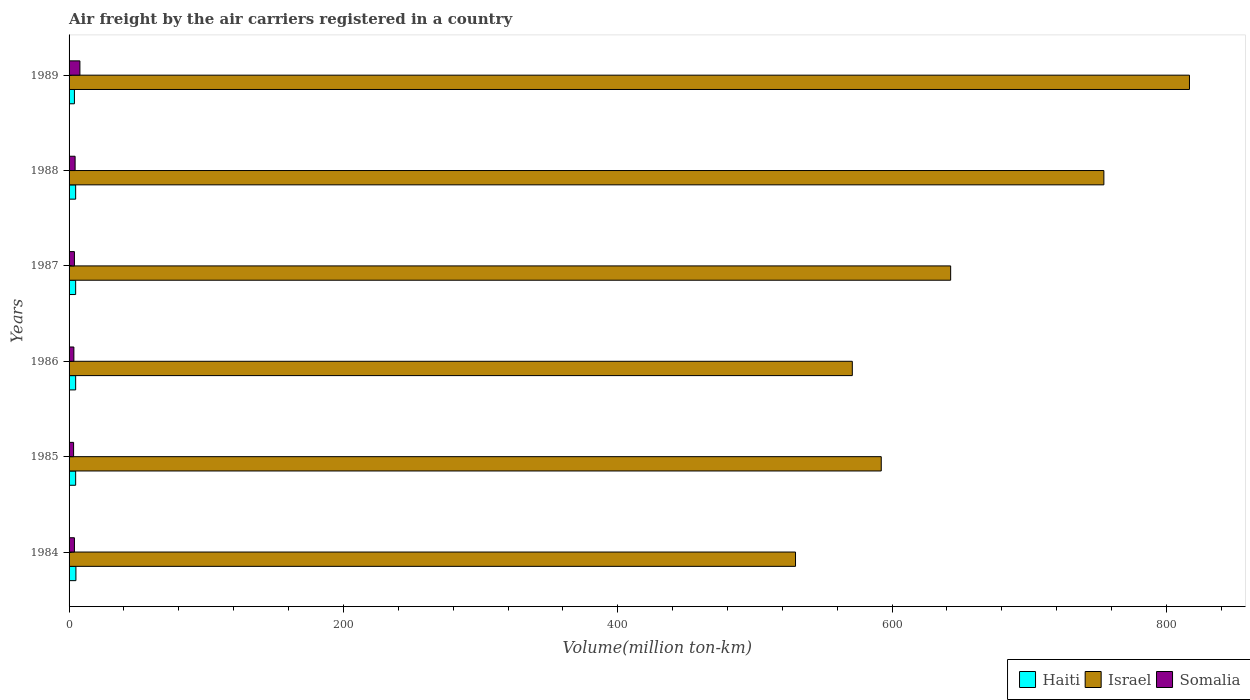How many different coloured bars are there?
Offer a terse response. 3. How many groups of bars are there?
Offer a very short reply. 6. How many bars are there on the 3rd tick from the top?
Provide a short and direct response. 3. How many bars are there on the 4th tick from the bottom?
Provide a succinct answer. 3. What is the volume of the air carriers in Haiti in 1988?
Your response must be concise. 4.8. Across all years, what is the maximum volume of the air carriers in Somalia?
Make the answer very short. 7.9. Across all years, what is the minimum volume of the air carriers in Somalia?
Your response must be concise. 3.3. In which year was the volume of the air carriers in Israel minimum?
Provide a succinct answer. 1984. What is the total volume of the air carriers in Somalia in the graph?
Your response must be concise. 26.9. What is the difference between the volume of the air carriers in Haiti in 1985 and the volume of the air carriers in Somalia in 1984?
Provide a succinct answer. 0.9. What is the average volume of the air carriers in Israel per year?
Your response must be concise. 651.1. In the year 1984, what is the difference between the volume of the air carriers in Israel and volume of the air carriers in Somalia?
Offer a terse response. 525.7. In how many years, is the volume of the air carriers in Israel greater than 440 million ton-km?
Your response must be concise. 6. What is the ratio of the volume of the air carriers in Israel in 1984 to that in 1986?
Your answer should be very brief. 0.93. Is the volume of the air carriers in Haiti in 1988 less than that in 1989?
Provide a short and direct response. No. What is the difference between the highest and the second highest volume of the air carriers in Haiti?
Your answer should be compact. 0.2. What is the difference between the highest and the lowest volume of the air carriers in Somalia?
Give a very brief answer. 4.6. In how many years, is the volume of the air carriers in Haiti greater than the average volume of the air carriers in Haiti taken over all years?
Give a very brief answer. 5. Is the sum of the volume of the air carriers in Somalia in 1984 and 1986 greater than the maximum volume of the air carriers in Israel across all years?
Your response must be concise. No. What does the 3rd bar from the top in 1989 represents?
Offer a very short reply. Haiti. What does the 2nd bar from the bottom in 1986 represents?
Provide a succinct answer. Israel. How many years are there in the graph?
Offer a terse response. 6. Are the values on the major ticks of X-axis written in scientific E-notation?
Your response must be concise. No. Does the graph contain any zero values?
Ensure brevity in your answer.  No. Does the graph contain grids?
Your response must be concise. No. Where does the legend appear in the graph?
Offer a terse response. Bottom right. How are the legend labels stacked?
Make the answer very short. Horizontal. What is the title of the graph?
Provide a short and direct response. Air freight by the air carriers registered in a country. Does "Jamaica" appear as one of the legend labels in the graph?
Offer a terse response. No. What is the label or title of the X-axis?
Give a very brief answer. Volume(million ton-km). What is the label or title of the Y-axis?
Provide a short and direct response. Years. What is the Volume(million ton-km) in Israel in 1984?
Your answer should be very brief. 529.6. What is the Volume(million ton-km) of Somalia in 1984?
Give a very brief answer. 3.9. What is the Volume(million ton-km) of Haiti in 1985?
Offer a very short reply. 4.8. What is the Volume(million ton-km) in Israel in 1985?
Your response must be concise. 592.1. What is the Volume(million ton-km) in Somalia in 1985?
Offer a very short reply. 3.3. What is the Volume(million ton-km) of Haiti in 1986?
Keep it short and to the point. 4.8. What is the Volume(million ton-km) in Israel in 1986?
Keep it short and to the point. 571. What is the Volume(million ton-km) of Haiti in 1987?
Give a very brief answer. 4.8. What is the Volume(million ton-km) in Israel in 1987?
Offer a very short reply. 642.7. What is the Volume(million ton-km) in Somalia in 1987?
Provide a succinct answer. 3.9. What is the Volume(million ton-km) of Haiti in 1988?
Provide a short and direct response. 4.8. What is the Volume(million ton-km) of Israel in 1988?
Ensure brevity in your answer.  754.4. What is the Volume(million ton-km) in Somalia in 1988?
Your answer should be compact. 4.4. What is the Volume(million ton-km) in Haiti in 1989?
Keep it short and to the point. 3.9. What is the Volume(million ton-km) in Israel in 1989?
Offer a terse response. 816.8. What is the Volume(million ton-km) of Somalia in 1989?
Your answer should be very brief. 7.9. Across all years, what is the maximum Volume(million ton-km) in Haiti?
Your answer should be compact. 5. Across all years, what is the maximum Volume(million ton-km) of Israel?
Give a very brief answer. 816.8. Across all years, what is the maximum Volume(million ton-km) of Somalia?
Offer a very short reply. 7.9. Across all years, what is the minimum Volume(million ton-km) in Haiti?
Offer a very short reply. 3.9. Across all years, what is the minimum Volume(million ton-km) in Israel?
Your answer should be compact. 529.6. Across all years, what is the minimum Volume(million ton-km) in Somalia?
Your answer should be compact. 3.3. What is the total Volume(million ton-km) in Haiti in the graph?
Offer a terse response. 28.1. What is the total Volume(million ton-km) of Israel in the graph?
Your answer should be compact. 3906.6. What is the total Volume(million ton-km) in Somalia in the graph?
Keep it short and to the point. 26.9. What is the difference between the Volume(million ton-km) of Haiti in 1984 and that in 1985?
Give a very brief answer. 0.2. What is the difference between the Volume(million ton-km) of Israel in 1984 and that in 1985?
Keep it short and to the point. -62.5. What is the difference between the Volume(million ton-km) of Israel in 1984 and that in 1986?
Your answer should be very brief. -41.4. What is the difference between the Volume(million ton-km) of Somalia in 1984 and that in 1986?
Keep it short and to the point. 0.4. What is the difference between the Volume(million ton-km) in Haiti in 1984 and that in 1987?
Offer a terse response. 0.2. What is the difference between the Volume(million ton-km) of Israel in 1984 and that in 1987?
Make the answer very short. -113.1. What is the difference between the Volume(million ton-km) of Somalia in 1984 and that in 1987?
Provide a succinct answer. 0. What is the difference between the Volume(million ton-km) in Israel in 1984 and that in 1988?
Provide a short and direct response. -224.8. What is the difference between the Volume(million ton-km) in Somalia in 1984 and that in 1988?
Your answer should be very brief. -0.5. What is the difference between the Volume(million ton-km) in Israel in 1984 and that in 1989?
Provide a short and direct response. -287.2. What is the difference between the Volume(million ton-km) of Somalia in 1984 and that in 1989?
Make the answer very short. -4. What is the difference between the Volume(million ton-km) of Israel in 1985 and that in 1986?
Your response must be concise. 21.1. What is the difference between the Volume(million ton-km) in Somalia in 1985 and that in 1986?
Your answer should be compact. -0.2. What is the difference between the Volume(million ton-km) of Haiti in 1985 and that in 1987?
Offer a very short reply. 0. What is the difference between the Volume(million ton-km) in Israel in 1985 and that in 1987?
Ensure brevity in your answer.  -50.6. What is the difference between the Volume(million ton-km) of Somalia in 1985 and that in 1987?
Offer a terse response. -0.6. What is the difference between the Volume(million ton-km) in Israel in 1985 and that in 1988?
Your answer should be very brief. -162.3. What is the difference between the Volume(million ton-km) of Somalia in 1985 and that in 1988?
Offer a terse response. -1.1. What is the difference between the Volume(million ton-km) in Israel in 1985 and that in 1989?
Make the answer very short. -224.7. What is the difference between the Volume(million ton-km) of Haiti in 1986 and that in 1987?
Make the answer very short. 0. What is the difference between the Volume(million ton-km) of Israel in 1986 and that in 1987?
Your answer should be compact. -71.7. What is the difference between the Volume(million ton-km) in Somalia in 1986 and that in 1987?
Your response must be concise. -0.4. What is the difference between the Volume(million ton-km) in Haiti in 1986 and that in 1988?
Ensure brevity in your answer.  0. What is the difference between the Volume(million ton-km) of Israel in 1986 and that in 1988?
Provide a short and direct response. -183.4. What is the difference between the Volume(million ton-km) in Haiti in 1986 and that in 1989?
Your answer should be compact. 0.9. What is the difference between the Volume(million ton-km) in Israel in 1986 and that in 1989?
Provide a short and direct response. -245.8. What is the difference between the Volume(million ton-km) of Somalia in 1986 and that in 1989?
Keep it short and to the point. -4.4. What is the difference between the Volume(million ton-km) of Haiti in 1987 and that in 1988?
Offer a terse response. 0. What is the difference between the Volume(million ton-km) of Israel in 1987 and that in 1988?
Keep it short and to the point. -111.7. What is the difference between the Volume(million ton-km) in Haiti in 1987 and that in 1989?
Your answer should be very brief. 0.9. What is the difference between the Volume(million ton-km) of Israel in 1987 and that in 1989?
Provide a succinct answer. -174.1. What is the difference between the Volume(million ton-km) in Israel in 1988 and that in 1989?
Provide a short and direct response. -62.4. What is the difference between the Volume(million ton-km) in Somalia in 1988 and that in 1989?
Ensure brevity in your answer.  -3.5. What is the difference between the Volume(million ton-km) of Haiti in 1984 and the Volume(million ton-km) of Israel in 1985?
Provide a short and direct response. -587.1. What is the difference between the Volume(million ton-km) of Haiti in 1984 and the Volume(million ton-km) of Somalia in 1985?
Give a very brief answer. 1.7. What is the difference between the Volume(million ton-km) in Israel in 1984 and the Volume(million ton-km) in Somalia in 1985?
Offer a terse response. 526.3. What is the difference between the Volume(million ton-km) of Haiti in 1984 and the Volume(million ton-km) of Israel in 1986?
Provide a succinct answer. -566. What is the difference between the Volume(million ton-km) in Haiti in 1984 and the Volume(million ton-km) in Somalia in 1986?
Keep it short and to the point. 1.5. What is the difference between the Volume(million ton-km) in Israel in 1984 and the Volume(million ton-km) in Somalia in 1986?
Offer a very short reply. 526.1. What is the difference between the Volume(million ton-km) in Haiti in 1984 and the Volume(million ton-km) in Israel in 1987?
Your answer should be very brief. -637.7. What is the difference between the Volume(million ton-km) in Israel in 1984 and the Volume(million ton-km) in Somalia in 1987?
Give a very brief answer. 525.7. What is the difference between the Volume(million ton-km) in Haiti in 1984 and the Volume(million ton-km) in Israel in 1988?
Your answer should be compact. -749.4. What is the difference between the Volume(million ton-km) of Israel in 1984 and the Volume(million ton-km) of Somalia in 1988?
Offer a very short reply. 525.2. What is the difference between the Volume(million ton-km) in Haiti in 1984 and the Volume(million ton-km) in Israel in 1989?
Keep it short and to the point. -811.8. What is the difference between the Volume(million ton-km) in Haiti in 1984 and the Volume(million ton-km) in Somalia in 1989?
Provide a succinct answer. -2.9. What is the difference between the Volume(million ton-km) of Israel in 1984 and the Volume(million ton-km) of Somalia in 1989?
Your response must be concise. 521.7. What is the difference between the Volume(million ton-km) in Haiti in 1985 and the Volume(million ton-km) in Israel in 1986?
Keep it short and to the point. -566.2. What is the difference between the Volume(million ton-km) in Haiti in 1985 and the Volume(million ton-km) in Somalia in 1986?
Offer a very short reply. 1.3. What is the difference between the Volume(million ton-km) of Israel in 1985 and the Volume(million ton-km) of Somalia in 1986?
Your answer should be compact. 588.6. What is the difference between the Volume(million ton-km) in Haiti in 1985 and the Volume(million ton-km) in Israel in 1987?
Provide a short and direct response. -637.9. What is the difference between the Volume(million ton-km) in Israel in 1985 and the Volume(million ton-km) in Somalia in 1987?
Keep it short and to the point. 588.2. What is the difference between the Volume(million ton-km) in Haiti in 1985 and the Volume(million ton-km) in Israel in 1988?
Provide a short and direct response. -749.6. What is the difference between the Volume(million ton-km) of Haiti in 1985 and the Volume(million ton-km) of Somalia in 1988?
Offer a very short reply. 0.4. What is the difference between the Volume(million ton-km) of Israel in 1985 and the Volume(million ton-km) of Somalia in 1988?
Your answer should be very brief. 587.7. What is the difference between the Volume(million ton-km) of Haiti in 1985 and the Volume(million ton-km) of Israel in 1989?
Provide a succinct answer. -812. What is the difference between the Volume(million ton-km) in Haiti in 1985 and the Volume(million ton-km) in Somalia in 1989?
Your answer should be compact. -3.1. What is the difference between the Volume(million ton-km) of Israel in 1985 and the Volume(million ton-km) of Somalia in 1989?
Keep it short and to the point. 584.2. What is the difference between the Volume(million ton-km) in Haiti in 1986 and the Volume(million ton-km) in Israel in 1987?
Give a very brief answer. -637.9. What is the difference between the Volume(million ton-km) of Israel in 1986 and the Volume(million ton-km) of Somalia in 1987?
Offer a terse response. 567.1. What is the difference between the Volume(million ton-km) in Haiti in 1986 and the Volume(million ton-km) in Israel in 1988?
Keep it short and to the point. -749.6. What is the difference between the Volume(million ton-km) in Haiti in 1986 and the Volume(million ton-km) in Somalia in 1988?
Offer a very short reply. 0.4. What is the difference between the Volume(million ton-km) in Israel in 1986 and the Volume(million ton-km) in Somalia in 1988?
Offer a very short reply. 566.6. What is the difference between the Volume(million ton-km) of Haiti in 1986 and the Volume(million ton-km) of Israel in 1989?
Offer a terse response. -812. What is the difference between the Volume(million ton-km) of Haiti in 1986 and the Volume(million ton-km) of Somalia in 1989?
Ensure brevity in your answer.  -3.1. What is the difference between the Volume(million ton-km) in Israel in 1986 and the Volume(million ton-km) in Somalia in 1989?
Your response must be concise. 563.1. What is the difference between the Volume(million ton-km) of Haiti in 1987 and the Volume(million ton-km) of Israel in 1988?
Ensure brevity in your answer.  -749.6. What is the difference between the Volume(million ton-km) in Haiti in 1987 and the Volume(million ton-km) in Somalia in 1988?
Give a very brief answer. 0.4. What is the difference between the Volume(million ton-km) in Israel in 1987 and the Volume(million ton-km) in Somalia in 1988?
Your answer should be very brief. 638.3. What is the difference between the Volume(million ton-km) of Haiti in 1987 and the Volume(million ton-km) of Israel in 1989?
Your response must be concise. -812. What is the difference between the Volume(million ton-km) in Israel in 1987 and the Volume(million ton-km) in Somalia in 1989?
Ensure brevity in your answer.  634.8. What is the difference between the Volume(million ton-km) of Haiti in 1988 and the Volume(million ton-km) of Israel in 1989?
Your answer should be very brief. -812. What is the difference between the Volume(million ton-km) of Haiti in 1988 and the Volume(million ton-km) of Somalia in 1989?
Provide a succinct answer. -3.1. What is the difference between the Volume(million ton-km) of Israel in 1988 and the Volume(million ton-km) of Somalia in 1989?
Provide a succinct answer. 746.5. What is the average Volume(million ton-km) in Haiti per year?
Offer a very short reply. 4.68. What is the average Volume(million ton-km) of Israel per year?
Ensure brevity in your answer.  651.1. What is the average Volume(million ton-km) of Somalia per year?
Provide a short and direct response. 4.48. In the year 1984, what is the difference between the Volume(million ton-km) of Haiti and Volume(million ton-km) of Israel?
Your response must be concise. -524.6. In the year 1984, what is the difference between the Volume(million ton-km) in Israel and Volume(million ton-km) in Somalia?
Give a very brief answer. 525.7. In the year 1985, what is the difference between the Volume(million ton-km) of Haiti and Volume(million ton-km) of Israel?
Your answer should be very brief. -587.3. In the year 1985, what is the difference between the Volume(million ton-km) in Israel and Volume(million ton-km) in Somalia?
Provide a short and direct response. 588.8. In the year 1986, what is the difference between the Volume(million ton-km) in Haiti and Volume(million ton-km) in Israel?
Make the answer very short. -566.2. In the year 1986, what is the difference between the Volume(million ton-km) in Israel and Volume(million ton-km) in Somalia?
Your answer should be very brief. 567.5. In the year 1987, what is the difference between the Volume(million ton-km) in Haiti and Volume(million ton-km) in Israel?
Ensure brevity in your answer.  -637.9. In the year 1987, what is the difference between the Volume(million ton-km) of Israel and Volume(million ton-km) of Somalia?
Keep it short and to the point. 638.8. In the year 1988, what is the difference between the Volume(million ton-km) in Haiti and Volume(million ton-km) in Israel?
Keep it short and to the point. -749.6. In the year 1988, what is the difference between the Volume(million ton-km) in Haiti and Volume(million ton-km) in Somalia?
Provide a succinct answer. 0.4. In the year 1988, what is the difference between the Volume(million ton-km) in Israel and Volume(million ton-km) in Somalia?
Offer a terse response. 750. In the year 1989, what is the difference between the Volume(million ton-km) of Haiti and Volume(million ton-km) of Israel?
Your answer should be compact. -812.9. In the year 1989, what is the difference between the Volume(million ton-km) in Israel and Volume(million ton-km) in Somalia?
Your response must be concise. 808.9. What is the ratio of the Volume(million ton-km) in Haiti in 1984 to that in 1985?
Your answer should be compact. 1.04. What is the ratio of the Volume(million ton-km) in Israel in 1984 to that in 1985?
Ensure brevity in your answer.  0.89. What is the ratio of the Volume(million ton-km) of Somalia in 1984 to that in 1985?
Provide a succinct answer. 1.18. What is the ratio of the Volume(million ton-km) in Haiti in 1984 to that in 1986?
Ensure brevity in your answer.  1.04. What is the ratio of the Volume(million ton-km) in Israel in 1984 to that in 1986?
Your answer should be compact. 0.93. What is the ratio of the Volume(million ton-km) in Somalia in 1984 to that in 1986?
Your answer should be very brief. 1.11. What is the ratio of the Volume(million ton-km) of Haiti in 1984 to that in 1987?
Give a very brief answer. 1.04. What is the ratio of the Volume(million ton-km) in Israel in 1984 to that in 1987?
Offer a terse response. 0.82. What is the ratio of the Volume(million ton-km) in Somalia in 1984 to that in 1987?
Ensure brevity in your answer.  1. What is the ratio of the Volume(million ton-km) of Haiti in 1984 to that in 1988?
Ensure brevity in your answer.  1.04. What is the ratio of the Volume(million ton-km) in Israel in 1984 to that in 1988?
Your answer should be compact. 0.7. What is the ratio of the Volume(million ton-km) of Somalia in 1984 to that in 1988?
Make the answer very short. 0.89. What is the ratio of the Volume(million ton-km) in Haiti in 1984 to that in 1989?
Your response must be concise. 1.28. What is the ratio of the Volume(million ton-km) in Israel in 1984 to that in 1989?
Ensure brevity in your answer.  0.65. What is the ratio of the Volume(million ton-km) of Somalia in 1984 to that in 1989?
Keep it short and to the point. 0.49. What is the ratio of the Volume(million ton-km) in Somalia in 1985 to that in 1986?
Provide a short and direct response. 0.94. What is the ratio of the Volume(million ton-km) in Haiti in 1985 to that in 1987?
Give a very brief answer. 1. What is the ratio of the Volume(million ton-km) in Israel in 1985 to that in 1987?
Keep it short and to the point. 0.92. What is the ratio of the Volume(million ton-km) of Somalia in 1985 to that in 1987?
Ensure brevity in your answer.  0.85. What is the ratio of the Volume(million ton-km) of Haiti in 1985 to that in 1988?
Your answer should be compact. 1. What is the ratio of the Volume(million ton-km) in Israel in 1985 to that in 1988?
Keep it short and to the point. 0.78. What is the ratio of the Volume(million ton-km) in Haiti in 1985 to that in 1989?
Your answer should be very brief. 1.23. What is the ratio of the Volume(million ton-km) in Israel in 1985 to that in 1989?
Your answer should be compact. 0.72. What is the ratio of the Volume(million ton-km) in Somalia in 1985 to that in 1989?
Your response must be concise. 0.42. What is the ratio of the Volume(million ton-km) of Israel in 1986 to that in 1987?
Give a very brief answer. 0.89. What is the ratio of the Volume(million ton-km) in Somalia in 1986 to that in 1987?
Keep it short and to the point. 0.9. What is the ratio of the Volume(million ton-km) in Israel in 1986 to that in 1988?
Your answer should be very brief. 0.76. What is the ratio of the Volume(million ton-km) of Somalia in 1986 to that in 1988?
Your response must be concise. 0.8. What is the ratio of the Volume(million ton-km) in Haiti in 1986 to that in 1989?
Provide a short and direct response. 1.23. What is the ratio of the Volume(million ton-km) of Israel in 1986 to that in 1989?
Give a very brief answer. 0.7. What is the ratio of the Volume(million ton-km) in Somalia in 1986 to that in 1989?
Make the answer very short. 0.44. What is the ratio of the Volume(million ton-km) in Israel in 1987 to that in 1988?
Give a very brief answer. 0.85. What is the ratio of the Volume(million ton-km) of Somalia in 1987 to that in 1988?
Your answer should be very brief. 0.89. What is the ratio of the Volume(million ton-km) of Haiti in 1987 to that in 1989?
Give a very brief answer. 1.23. What is the ratio of the Volume(million ton-km) in Israel in 1987 to that in 1989?
Your answer should be very brief. 0.79. What is the ratio of the Volume(million ton-km) in Somalia in 1987 to that in 1989?
Ensure brevity in your answer.  0.49. What is the ratio of the Volume(million ton-km) in Haiti in 1988 to that in 1989?
Keep it short and to the point. 1.23. What is the ratio of the Volume(million ton-km) of Israel in 1988 to that in 1989?
Your response must be concise. 0.92. What is the ratio of the Volume(million ton-km) of Somalia in 1988 to that in 1989?
Make the answer very short. 0.56. What is the difference between the highest and the second highest Volume(million ton-km) of Haiti?
Your answer should be compact. 0.2. What is the difference between the highest and the second highest Volume(million ton-km) of Israel?
Your answer should be compact. 62.4. What is the difference between the highest and the lowest Volume(million ton-km) of Israel?
Make the answer very short. 287.2. 